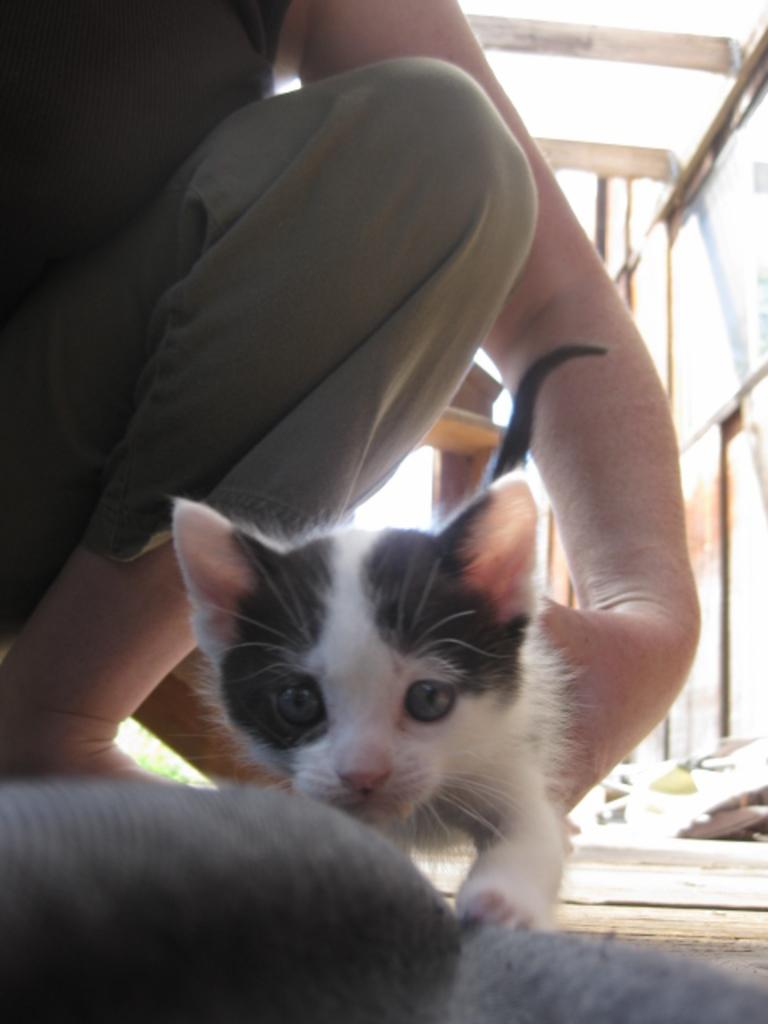What is the main subject of the image? There is a person in the image. What is the person holding in the image? The person is holding a cat. Can you describe the appearance of the cat? The cat has white and grey colors. What type of support can be seen in the image for the duck to lean on? There is no duck present in the image, so there is no support for a duck. What type of beef is being cooked in the image? There is no beef or cooking activity depicted in the image. 